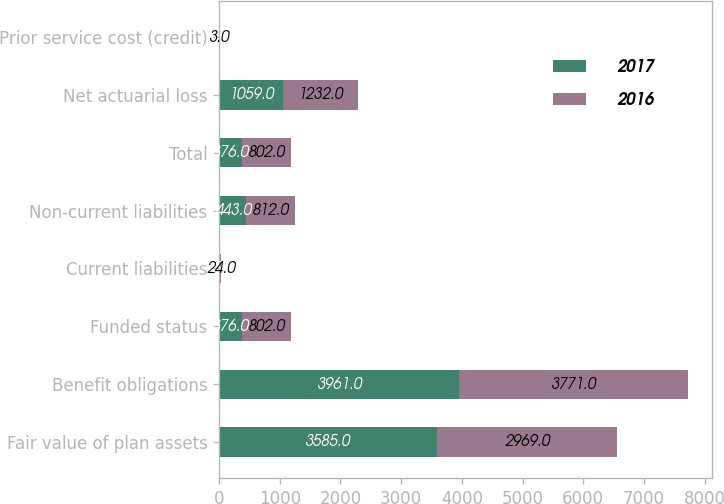Convert chart to OTSL. <chart><loc_0><loc_0><loc_500><loc_500><stacked_bar_chart><ecel><fcel>Fair value of plan assets<fcel>Benefit obligations<fcel>Funded status<fcel>Current liabilities<fcel>Non-current liabilities<fcel>Total<fcel>Net actuarial loss<fcel>Prior service cost (credit)<nl><fcel>2017<fcel>3585<fcel>3961<fcel>376<fcel>15<fcel>443<fcel>376<fcel>1059<fcel>4<nl><fcel>2016<fcel>2969<fcel>3771<fcel>802<fcel>24<fcel>812<fcel>802<fcel>1232<fcel>3<nl></chart> 